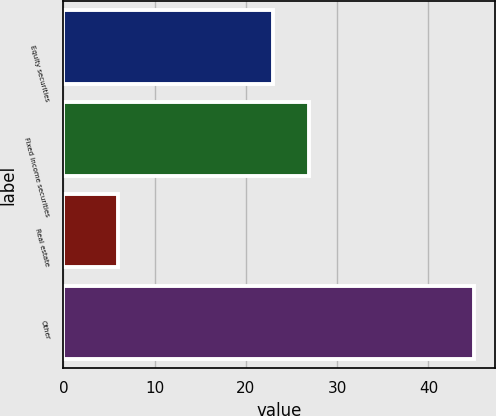Convert chart. <chart><loc_0><loc_0><loc_500><loc_500><bar_chart><fcel>Equity securities<fcel>Fixed income securities<fcel>Real estate<fcel>Other<nl><fcel>23<fcel>26.9<fcel>6<fcel>45<nl></chart> 